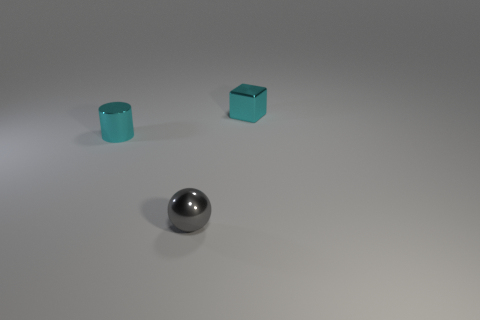How many other things are there of the same color as the tiny metal cube?
Your response must be concise. 1. What is the size of the block?
Provide a succinct answer. Small. Are any cyan shiny cubes visible?
Provide a short and direct response. Yes. Are there more shiny blocks to the left of the small block than gray metallic objects that are left of the tiny gray sphere?
Offer a very short reply. No. There is a thing that is both right of the small cylinder and in front of the metal cube; what material is it?
Give a very brief answer. Metal. Is there any other thing that is the same size as the cyan cylinder?
Provide a succinct answer. Yes. How many metal cylinders are behind the block?
Give a very brief answer. 0. Is the size of the cyan thing left of the metallic ball the same as the tiny sphere?
Your answer should be very brief. Yes. Is there anything else that is the same shape as the tiny gray thing?
Ensure brevity in your answer.  No. There is a cyan metallic thing right of the tiny cyan cylinder; what shape is it?
Offer a terse response. Cube. 